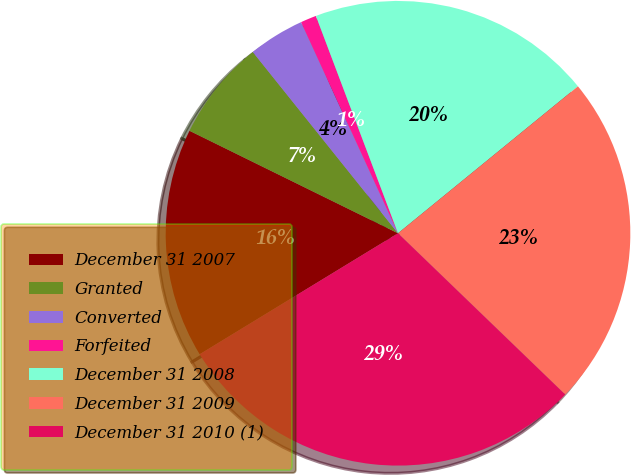Convert chart to OTSL. <chart><loc_0><loc_0><loc_500><loc_500><pie_chart><fcel>December 31 2007<fcel>Granted<fcel>Converted<fcel>Forfeited<fcel>December 31 2008<fcel>December 31 2009<fcel>December 31 2010 (1)<nl><fcel>15.99%<fcel>6.98%<fcel>3.9%<fcel>1.1%<fcel>19.85%<fcel>23.11%<fcel>29.07%<nl></chart> 